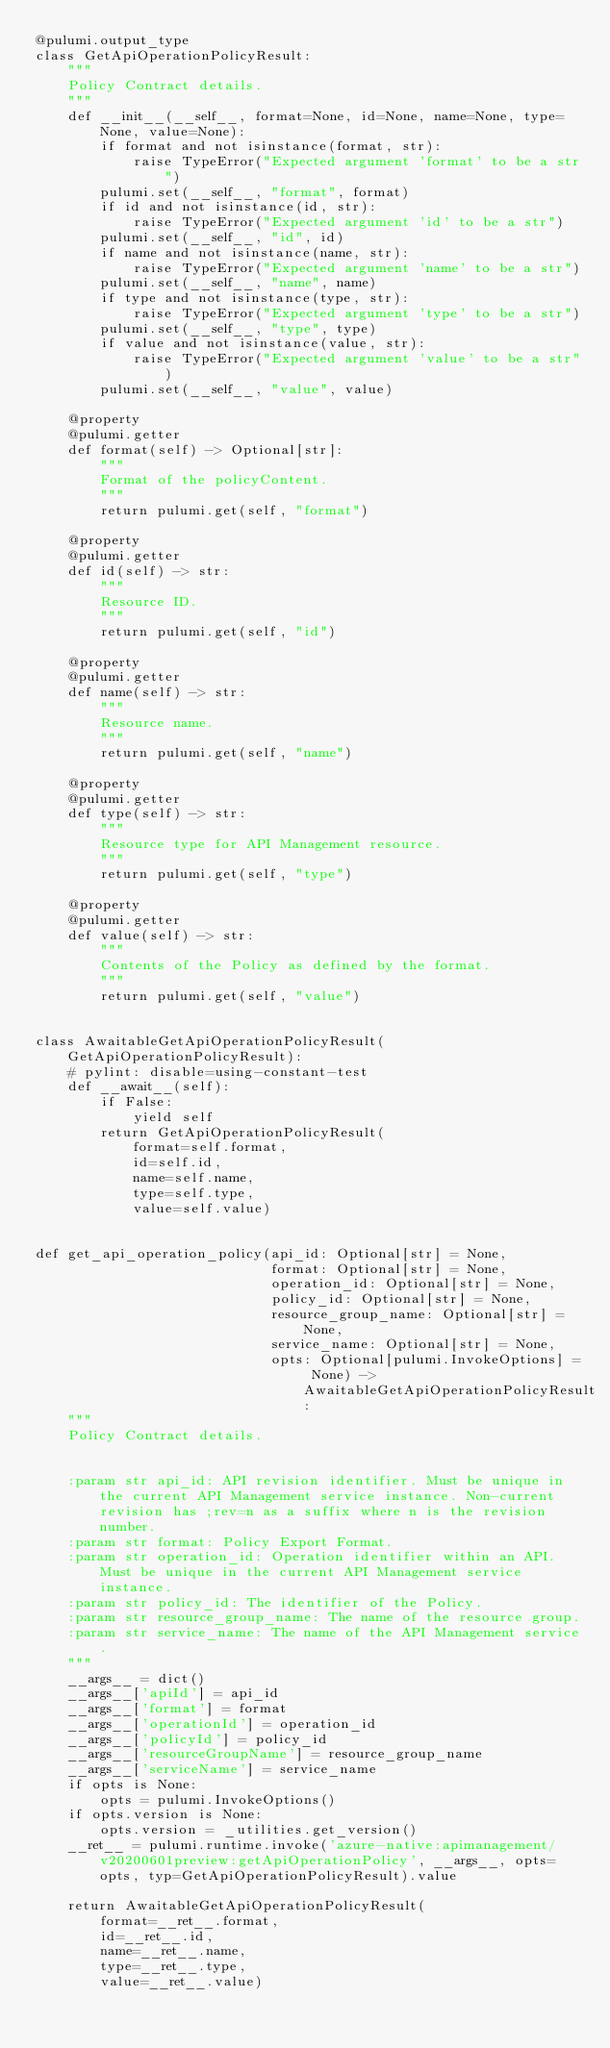<code> <loc_0><loc_0><loc_500><loc_500><_Python_>@pulumi.output_type
class GetApiOperationPolicyResult:
    """
    Policy Contract details.
    """
    def __init__(__self__, format=None, id=None, name=None, type=None, value=None):
        if format and not isinstance(format, str):
            raise TypeError("Expected argument 'format' to be a str")
        pulumi.set(__self__, "format", format)
        if id and not isinstance(id, str):
            raise TypeError("Expected argument 'id' to be a str")
        pulumi.set(__self__, "id", id)
        if name and not isinstance(name, str):
            raise TypeError("Expected argument 'name' to be a str")
        pulumi.set(__self__, "name", name)
        if type and not isinstance(type, str):
            raise TypeError("Expected argument 'type' to be a str")
        pulumi.set(__self__, "type", type)
        if value and not isinstance(value, str):
            raise TypeError("Expected argument 'value' to be a str")
        pulumi.set(__self__, "value", value)

    @property
    @pulumi.getter
    def format(self) -> Optional[str]:
        """
        Format of the policyContent.
        """
        return pulumi.get(self, "format")

    @property
    @pulumi.getter
    def id(self) -> str:
        """
        Resource ID.
        """
        return pulumi.get(self, "id")

    @property
    @pulumi.getter
    def name(self) -> str:
        """
        Resource name.
        """
        return pulumi.get(self, "name")

    @property
    @pulumi.getter
    def type(self) -> str:
        """
        Resource type for API Management resource.
        """
        return pulumi.get(self, "type")

    @property
    @pulumi.getter
    def value(self) -> str:
        """
        Contents of the Policy as defined by the format.
        """
        return pulumi.get(self, "value")


class AwaitableGetApiOperationPolicyResult(GetApiOperationPolicyResult):
    # pylint: disable=using-constant-test
    def __await__(self):
        if False:
            yield self
        return GetApiOperationPolicyResult(
            format=self.format,
            id=self.id,
            name=self.name,
            type=self.type,
            value=self.value)


def get_api_operation_policy(api_id: Optional[str] = None,
                             format: Optional[str] = None,
                             operation_id: Optional[str] = None,
                             policy_id: Optional[str] = None,
                             resource_group_name: Optional[str] = None,
                             service_name: Optional[str] = None,
                             opts: Optional[pulumi.InvokeOptions] = None) -> AwaitableGetApiOperationPolicyResult:
    """
    Policy Contract details.


    :param str api_id: API revision identifier. Must be unique in the current API Management service instance. Non-current revision has ;rev=n as a suffix where n is the revision number.
    :param str format: Policy Export Format.
    :param str operation_id: Operation identifier within an API. Must be unique in the current API Management service instance.
    :param str policy_id: The identifier of the Policy.
    :param str resource_group_name: The name of the resource group.
    :param str service_name: The name of the API Management service.
    """
    __args__ = dict()
    __args__['apiId'] = api_id
    __args__['format'] = format
    __args__['operationId'] = operation_id
    __args__['policyId'] = policy_id
    __args__['resourceGroupName'] = resource_group_name
    __args__['serviceName'] = service_name
    if opts is None:
        opts = pulumi.InvokeOptions()
    if opts.version is None:
        opts.version = _utilities.get_version()
    __ret__ = pulumi.runtime.invoke('azure-native:apimanagement/v20200601preview:getApiOperationPolicy', __args__, opts=opts, typ=GetApiOperationPolicyResult).value

    return AwaitableGetApiOperationPolicyResult(
        format=__ret__.format,
        id=__ret__.id,
        name=__ret__.name,
        type=__ret__.type,
        value=__ret__.value)
</code> 